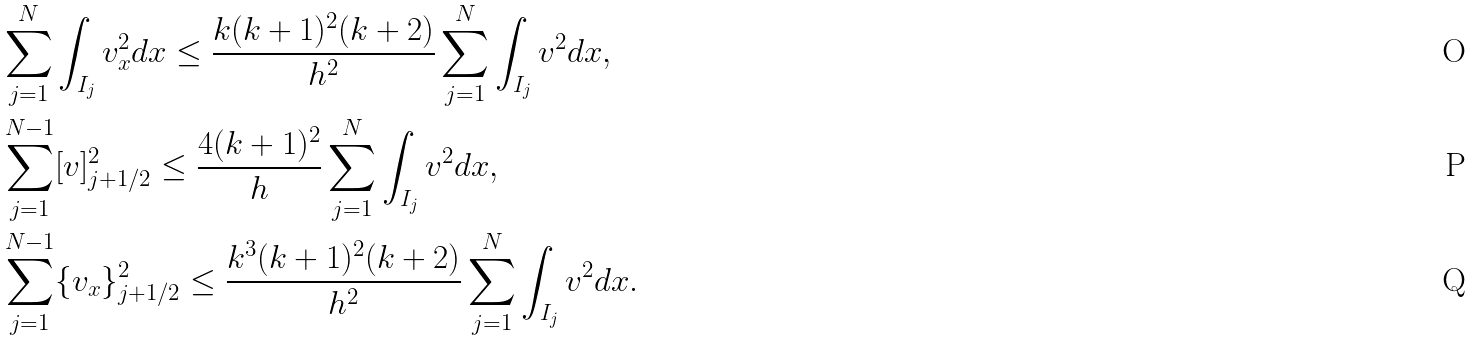Convert formula to latex. <formula><loc_0><loc_0><loc_500><loc_500>& \sum _ { j = 1 } ^ { N } \int _ { I _ { j } } v _ { x } ^ { 2 } d x \leq \frac { k ( k + 1 ) ^ { 2 } ( k + 2 ) } { h ^ { 2 } } \sum _ { j = 1 } ^ { N } \int _ { I _ { j } } v ^ { 2 } d x , \\ & \sum _ { j = 1 } ^ { N - 1 } [ v ] ^ { 2 } _ { j + 1 / 2 } \leq \frac { 4 ( k + 1 ) ^ { 2 } } { h } \sum _ { j = 1 } ^ { N } \int _ { I _ { j } } v ^ { 2 } d x , \\ & \sum _ { j = 1 } ^ { N - 1 } \{ v _ { x } \} ^ { 2 } _ { j + 1 / 2 } \leq \frac { k ^ { 3 } ( k + 1 ) ^ { 2 } ( k + 2 ) } { h ^ { 2 } } \sum _ { j = 1 } ^ { N } \int _ { I _ { j } } v ^ { 2 } d x .</formula> 